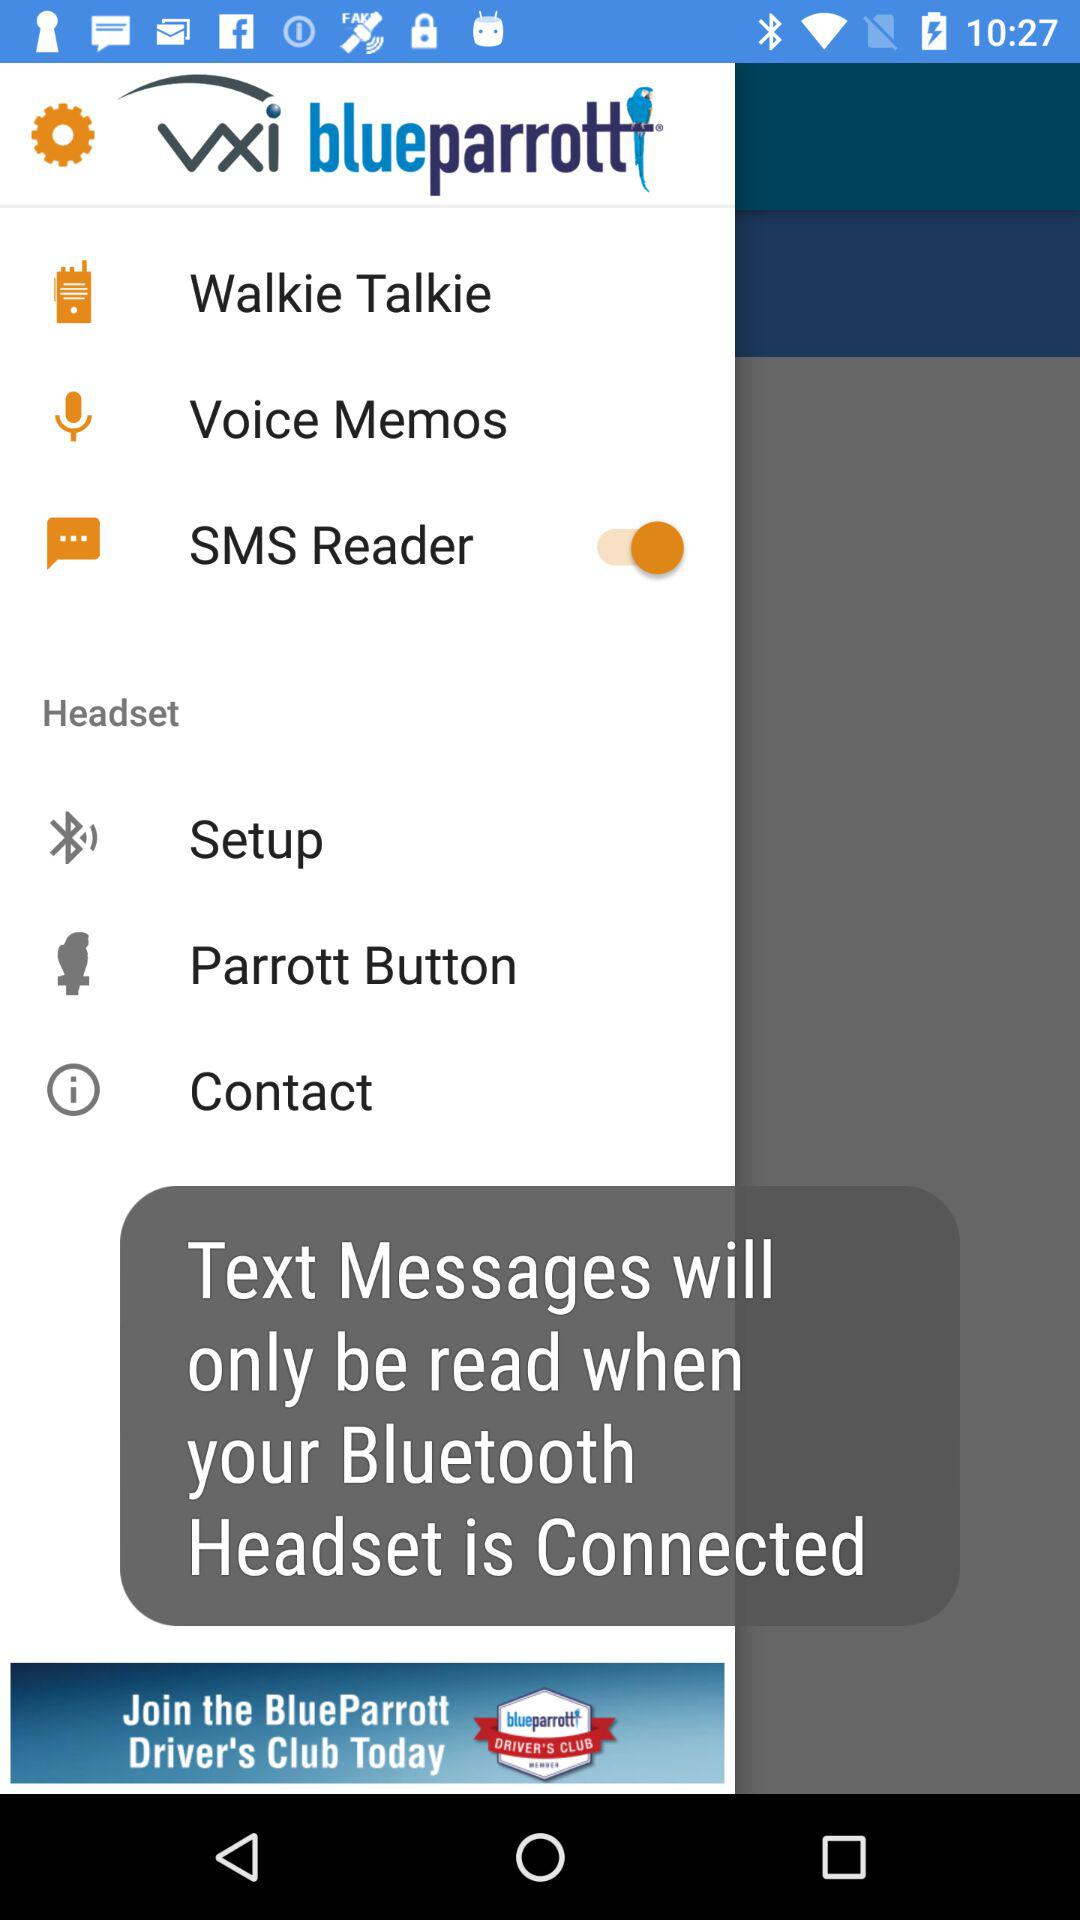When will the text messages be read? The text messages will be read when your Bluetooth headset is connected. 